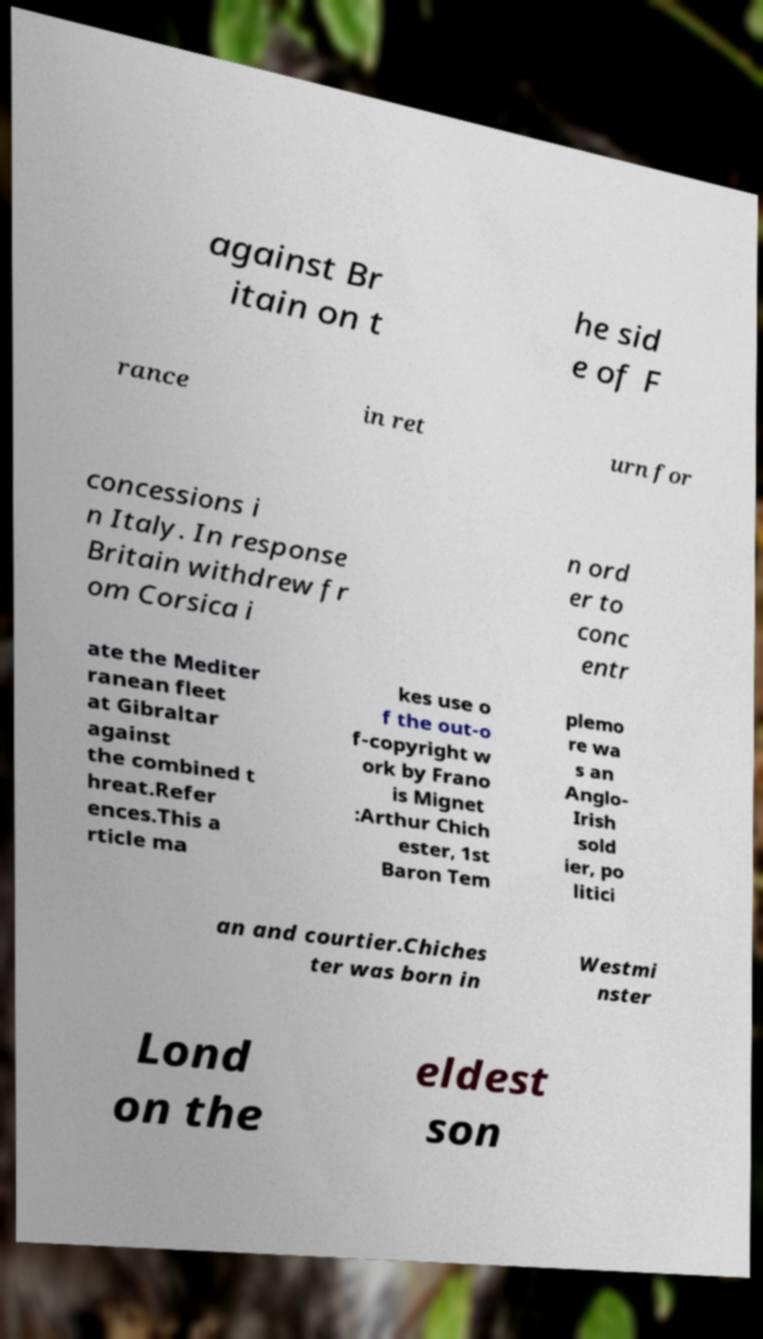Could you extract and type out the text from this image? against Br itain on t he sid e of F rance in ret urn for concessions i n Italy. In response Britain withdrew fr om Corsica i n ord er to conc entr ate the Mediter ranean fleet at Gibraltar against the combined t hreat.Refer ences.This a rticle ma kes use o f the out-o f-copyright w ork by Frano is Mignet :Arthur Chich ester, 1st Baron Tem plemo re wa s an Anglo- Irish sold ier, po litici an and courtier.Chiches ter was born in Westmi nster Lond on the eldest son 